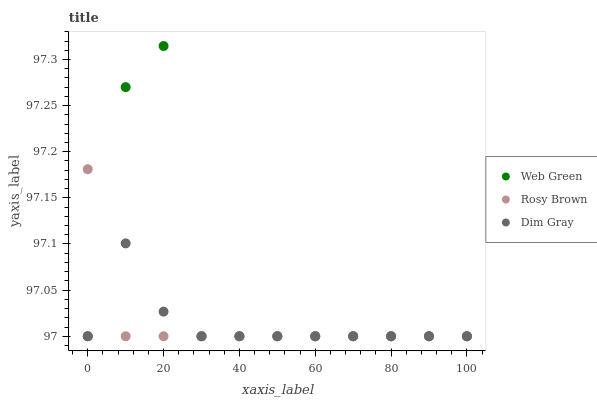Does Rosy Brown have the minimum area under the curve?
Answer yes or no. Yes. Does Web Green have the maximum area under the curve?
Answer yes or no. Yes. Does Web Green have the minimum area under the curve?
Answer yes or no. No. Does Rosy Brown have the maximum area under the curve?
Answer yes or no. No. Is Rosy Brown the smoothest?
Answer yes or no. Yes. Is Web Green the roughest?
Answer yes or no. Yes. Is Web Green the smoothest?
Answer yes or no. No. Is Rosy Brown the roughest?
Answer yes or no. No. Does Dim Gray have the lowest value?
Answer yes or no. Yes. Does Web Green have the highest value?
Answer yes or no. Yes. Does Rosy Brown have the highest value?
Answer yes or no. No. Does Rosy Brown intersect Dim Gray?
Answer yes or no. Yes. Is Rosy Brown less than Dim Gray?
Answer yes or no. No. Is Rosy Brown greater than Dim Gray?
Answer yes or no. No. 